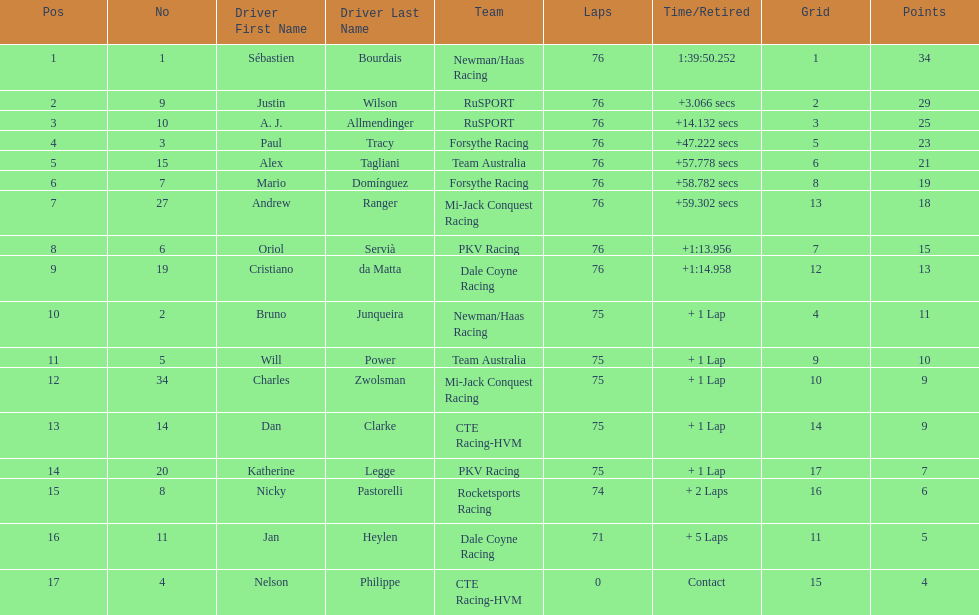Which driver earned the least amount of points. Nelson Philippe. 